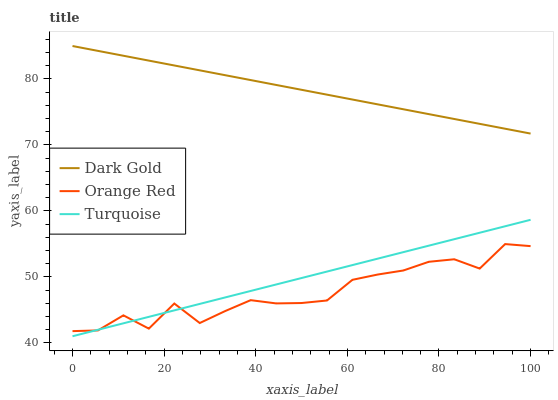Does Orange Red have the minimum area under the curve?
Answer yes or no. Yes. Does Dark Gold have the maximum area under the curve?
Answer yes or no. Yes. Does Dark Gold have the minimum area under the curve?
Answer yes or no. No. Does Orange Red have the maximum area under the curve?
Answer yes or no. No. Is Turquoise the smoothest?
Answer yes or no. Yes. Is Orange Red the roughest?
Answer yes or no. Yes. Is Dark Gold the smoothest?
Answer yes or no. No. Is Dark Gold the roughest?
Answer yes or no. No. Does Turquoise have the lowest value?
Answer yes or no. Yes. Does Orange Red have the lowest value?
Answer yes or no. No. Does Dark Gold have the highest value?
Answer yes or no. Yes. Does Orange Red have the highest value?
Answer yes or no. No. Is Orange Red less than Dark Gold?
Answer yes or no. Yes. Is Dark Gold greater than Turquoise?
Answer yes or no. Yes. Does Orange Red intersect Turquoise?
Answer yes or no. Yes. Is Orange Red less than Turquoise?
Answer yes or no. No. Is Orange Red greater than Turquoise?
Answer yes or no. No. Does Orange Red intersect Dark Gold?
Answer yes or no. No. 